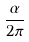<formula> <loc_0><loc_0><loc_500><loc_500>\frac { \alpha } { 2 \pi }</formula> 